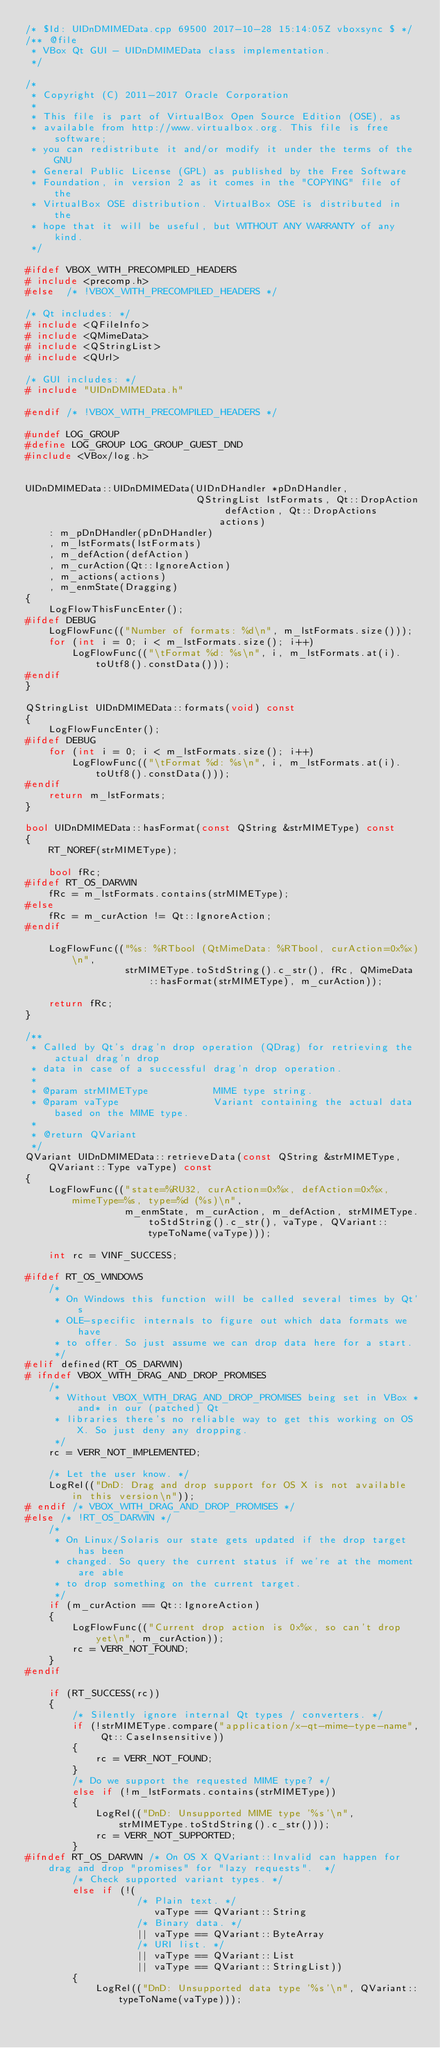<code> <loc_0><loc_0><loc_500><loc_500><_C++_>/* $Id: UIDnDMIMEData.cpp 69500 2017-10-28 15:14:05Z vboxsync $ */
/** @file
 * VBox Qt GUI - UIDnDMIMEData class implementation.
 */

/*
 * Copyright (C) 2011-2017 Oracle Corporation
 *
 * This file is part of VirtualBox Open Source Edition (OSE), as
 * available from http://www.virtualbox.org. This file is free software;
 * you can redistribute it and/or modify it under the terms of the GNU
 * General Public License (GPL) as published by the Free Software
 * Foundation, in version 2 as it comes in the "COPYING" file of the
 * VirtualBox OSE distribution. VirtualBox OSE is distributed in the
 * hope that it will be useful, but WITHOUT ANY WARRANTY of any kind.
 */

#ifdef VBOX_WITH_PRECOMPILED_HEADERS
# include <precomp.h>
#else  /* !VBOX_WITH_PRECOMPILED_HEADERS */

/* Qt includes: */
# include <QFileInfo>
# include <QMimeData>
# include <QStringList>
# include <QUrl>

/* GUI includes: */
# include "UIDnDMIMEData.h"

#endif /* !VBOX_WITH_PRECOMPILED_HEADERS */

#undef LOG_GROUP
#define LOG_GROUP LOG_GROUP_GUEST_DND
#include <VBox/log.h>


UIDnDMIMEData::UIDnDMIMEData(UIDnDHandler *pDnDHandler,
                             QStringList lstFormats, Qt::DropAction defAction, Qt::DropActions actions)
    : m_pDnDHandler(pDnDHandler)
    , m_lstFormats(lstFormats)
    , m_defAction(defAction)
    , m_curAction(Qt::IgnoreAction)
    , m_actions(actions)
    , m_enmState(Dragging)
{
    LogFlowThisFuncEnter();
#ifdef DEBUG
    LogFlowFunc(("Number of formats: %d\n", m_lstFormats.size()));
    for (int i = 0; i < m_lstFormats.size(); i++)
        LogFlowFunc(("\tFormat %d: %s\n", i, m_lstFormats.at(i).toUtf8().constData()));
#endif
}

QStringList UIDnDMIMEData::formats(void) const
{
    LogFlowFuncEnter();
#ifdef DEBUG
    for (int i = 0; i < m_lstFormats.size(); i++)
        LogFlowFunc(("\tFormat %d: %s\n", i, m_lstFormats.at(i).toUtf8().constData()));
#endif
    return m_lstFormats;
}

bool UIDnDMIMEData::hasFormat(const QString &strMIMEType) const
{
    RT_NOREF(strMIMEType);

    bool fRc;
#ifdef RT_OS_DARWIN
    fRc = m_lstFormats.contains(strMIMEType);
#else
    fRc = m_curAction != Qt::IgnoreAction;
#endif

    LogFlowFunc(("%s: %RTbool (QtMimeData: %RTbool, curAction=0x%x)\n",
                 strMIMEType.toStdString().c_str(), fRc, QMimeData::hasFormat(strMIMEType), m_curAction));

    return fRc;
}

/**
 * Called by Qt's drag'n drop operation (QDrag) for retrieving the actual drag'n drop
 * data in case of a successful drag'n drop operation.
 *
 * @param strMIMEType           MIME type string.
 * @param vaType                Variant containing the actual data based on the MIME type.
 *
 * @return QVariant
 */
QVariant UIDnDMIMEData::retrieveData(const QString &strMIMEType, QVariant::Type vaType) const
{
    LogFlowFunc(("state=%RU32, curAction=0x%x, defAction=0x%x, mimeType=%s, type=%d (%s)\n",
                 m_enmState, m_curAction, m_defAction, strMIMEType.toStdString().c_str(), vaType, QVariant::typeToName(vaType)));

    int rc = VINF_SUCCESS;

#ifdef RT_OS_WINDOWS
    /*
     * On Windows this function will be called several times by Qt's
     * OLE-specific internals to figure out which data formats we have
     * to offer. So just assume we can drop data here for a start.
     */
#elif defined(RT_OS_DARWIN)
# ifndef VBOX_WITH_DRAG_AND_DROP_PROMISES
    /*
     * Without VBOX_WITH_DRAG_AND_DROP_PROMISES being set in VBox *and* in our (patched) Qt
     * libraries there's no reliable way to get this working on OS X. So just deny any dropping.
     */
    rc = VERR_NOT_IMPLEMENTED;

    /* Let the user know. */
    LogRel(("DnD: Drag and drop support for OS X is not available in this version\n"));
# endif /* VBOX_WITH_DRAG_AND_DROP_PROMISES */
#else /* !RT_OS_DARWIN */
    /*
     * On Linux/Solaris our state gets updated if the drop target has been
     * changed. So query the current status if we're at the moment are able
     * to drop something on the current target.
     */
    if (m_curAction == Qt::IgnoreAction)
    {
        LogFlowFunc(("Current drop action is 0x%x, so can't drop yet\n", m_curAction));
        rc = VERR_NOT_FOUND;
    }
#endif

    if (RT_SUCCESS(rc))
    {
        /* Silently ignore internal Qt types / converters. */
        if (!strMIMEType.compare("application/x-qt-mime-type-name", Qt::CaseInsensitive))
        {
            rc = VERR_NOT_FOUND;
        }
        /* Do we support the requested MIME type? */
        else if (!m_lstFormats.contains(strMIMEType))
        {
            LogRel(("DnD: Unsupported MIME type '%s'\n", strMIMEType.toStdString().c_str()));
            rc = VERR_NOT_SUPPORTED;
        }
#ifndef RT_OS_DARWIN /* On OS X QVariant::Invalid can happen for drag and drop "promises" for "lazy requests".  */
        /* Check supported variant types. */
        else if (!(
                   /* Plain text. */
                      vaType == QVariant::String
                   /* Binary data. */
                   || vaType == QVariant::ByteArray
                   /* URI list. */
                   || vaType == QVariant::List
                   || vaType == QVariant::StringList))
        {
            LogRel(("DnD: Unsupported data type '%s'\n", QVariant::typeToName(vaType)));</code> 